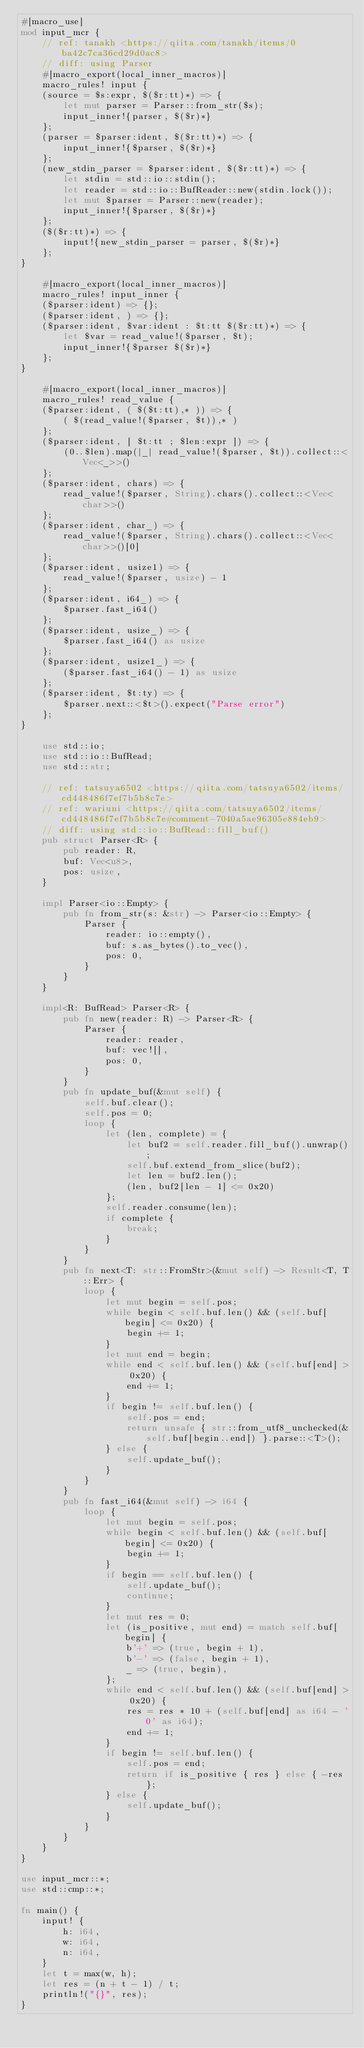<code> <loc_0><loc_0><loc_500><loc_500><_Rust_>#[macro_use]
mod input_mcr {
    // ref: tanakh <https://qiita.com/tanakh/items/0ba42c7ca36cd29d0ac8>
    // diff: using Parser
    #[macro_export(local_inner_macros)]
    macro_rules! input {
    (source = $s:expr, $($r:tt)*) => {
        let mut parser = Parser::from_str($s);
        input_inner!{parser, $($r)*}
    };
    (parser = $parser:ident, $($r:tt)*) => {
        input_inner!{$parser, $($r)*}
    };
    (new_stdin_parser = $parser:ident, $($r:tt)*) => {
        let stdin = std::io::stdin();
        let reader = std::io::BufReader::new(stdin.lock());
        let mut $parser = Parser::new(reader);
        input_inner!{$parser, $($r)*}
    };
    ($($r:tt)*) => {
        input!{new_stdin_parser = parser, $($r)*}
    };
}

    #[macro_export(local_inner_macros)]
    macro_rules! input_inner {
    ($parser:ident) => {};
    ($parser:ident, ) => {};
    ($parser:ident, $var:ident : $t:tt $($r:tt)*) => {
        let $var = read_value!($parser, $t);
        input_inner!{$parser $($r)*}
    };
}

    #[macro_export(local_inner_macros)]
    macro_rules! read_value {
    ($parser:ident, ( $($t:tt),* )) => {
        ( $(read_value!($parser, $t)),* )
    };
    ($parser:ident, [ $t:tt ; $len:expr ]) => {
        (0..$len).map(|_| read_value!($parser, $t)).collect::<Vec<_>>()
    };
    ($parser:ident, chars) => {
        read_value!($parser, String).chars().collect::<Vec<char>>()
    };
    ($parser:ident, char_) => {
        read_value!($parser, String).chars().collect::<Vec<char>>()[0]
    };
    ($parser:ident, usize1) => {
        read_value!($parser, usize) - 1
    };
    ($parser:ident, i64_) => {
        $parser.fast_i64()
    };
    ($parser:ident, usize_) => {
        $parser.fast_i64() as usize
    };
    ($parser:ident, usize1_) => {
        ($parser.fast_i64() - 1) as usize
    };
    ($parser:ident, $t:ty) => {
        $parser.next::<$t>().expect("Parse error")
    };
}

    use std::io;
    use std::io::BufRead;
    use std::str;

    // ref: tatsuya6502 <https://qiita.com/tatsuya6502/items/cd448486f7ef7b5b8c7e>
    // ref: wariuni <https://qiita.com/tatsuya6502/items/cd448486f7ef7b5b8c7e#comment-7040a5ae96305e884eb9>
    // diff: using std::io::BufRead::fill_buf()
    pub struct Parser<R> {
        pub reader: R,
        buf: Vec<u8>,
        pos: usize,
    }

    impl Parser<io::Empty> {
        pub fn from_str(s: &str) -> Parser<io::Empty> {
            Parser {
                reader: io::empty(),
                buf: s.as_bytes().to_vec(),
                pos: 0,
            }
        }
    }

    impl<R: BufRead> Parser<R> {
        pub fn new(reader: R) -> Parser<R> {
            Parser {
                reader: reader,
                buf: vec![],
                pos: 0,
            }
        }
        pub fn update_buf(&mut self) {
            self.buf.clear();
            self.pos = 0;
            loop {
                let (len, complete) = {
                    let buf2 = self.reader.fill_buf().unwrap();
                    self.buf.extend_from_slice(buf2);
                    let len = buf2.len();
                    (len, buf2[len - 1] <= 0x20)
                };
                self.reader.consume(len);
                if complete {
                    break;
                }
            }
        }
        pub fn next<T: str::FromStr>(&mut self) -> Result<T, T::Err> {
            loop {
                let mut begin = self.pos;
                while begin < self.buf.len() && (self.buf[begin] <= 0x20) {
                    begin += 1;
                }
                let mut end = begin;
                while end < self.buf.len() && (self.buf[end] > 0x20) {
                    end += 1;
                }
                if begin != self.buf.len() {
                    self.pos = end;
                    return unsafe { str::from_utf8_unchecked(&self.buf[begin..end]) }.parse::<T>();
                } else {
                    self.update_buf();
                }
            }
        }
        pub fn fast_i64(&mut self) -> i64 {
            loop {
                let mut begin = self.pos;
                while begin < self.buf.len() && (self.buf[begin] <= 0x20) {
                    begin += 1;
                }
                if begin == self.buf.len() {
                    self.update_buf();
                    continue;
                }
                let mut res = 0;
                let (is_positive, mut end) = match self.buf[begin] {
                    b'+' => (true, begin + 1),
                    b'-' => (false, begin + 1),
                    _ => (true, begin),
                };
                while end < self.buf.len() && (self.buf[end] > 0x20) {
                    res = res * 10 + (self.buf[end] as i64 - '0' as i64);
                    end += 1;
                }
                if begin != self.buf.len() {
                    self.pos = end;
                    return if is_positive { res } else { -res };
                } else {
                    self.update_buf();
                }
            }
        }
    }
}

use input_mcr::*;
use std::cmp::*;

fn main() {
    input! {
        h: i64,
        w: i64,
        n: i64,
    }
    let t = max(w, h);
    let res = (n + t - 1) / t;
    println!("{}", res);
}

</code> 